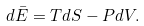Convert formula to latex. <formula><loc_0><loc_0><loc_500><loc_500>d \bar { E } = T d S - P d V .</formula> 